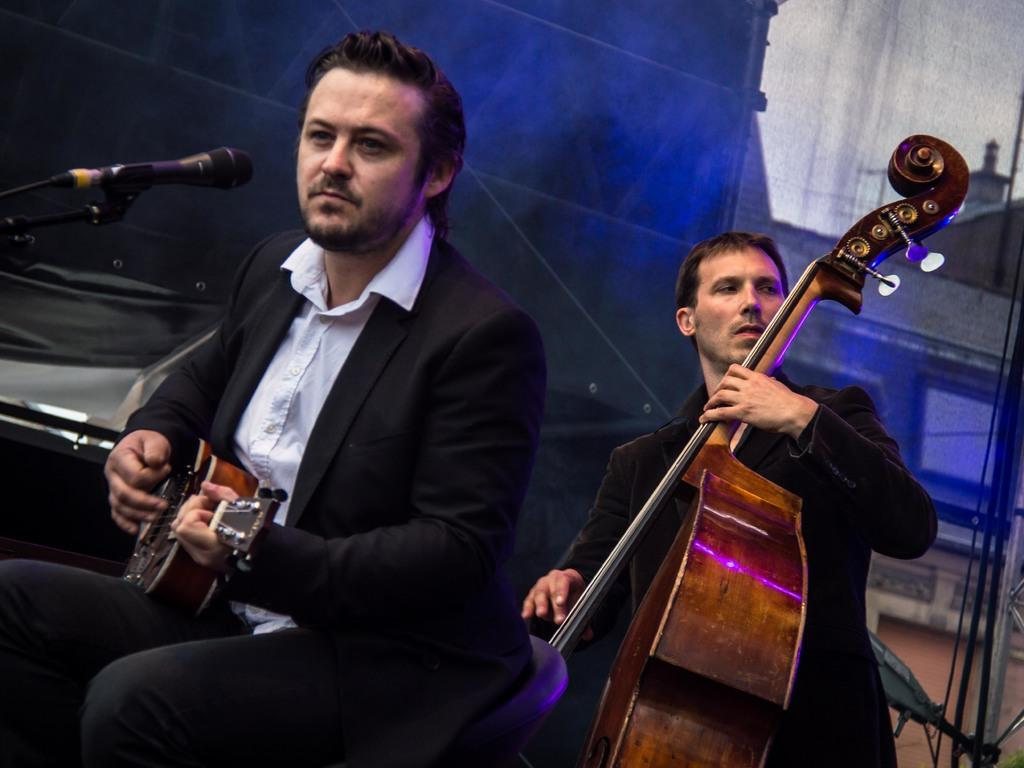What is the man in the image doing? The man is sitting and playing a guitar in the image. Is there anyone else in the image? Yes, there is another person standing in the image. What is the standing person doing? The standing person is also playing a guitar. What object does the sitting person have? The sitting person has a microphone. What type of song is the man singing in the image? There is no indication in the image that the man is singing, so it cannot be determined what song he might be singing. 